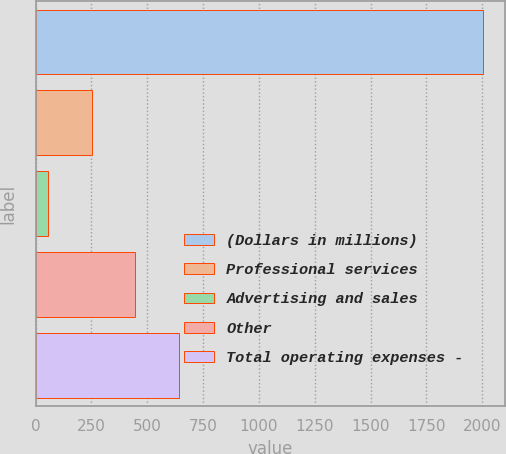Convert chart. <chart><loc_0><loc_0><loc_500><loc_500><bar_chart><fcel>(Dollars in millions)<fcel>Professional services<fcel>Advertising and sales<fcel>Other<fcel>Total operating expenses -<nl><fcel>2001<fcel>251.4<fcel>57<fcel>445.8<fcel>640.2<nl></chart> 